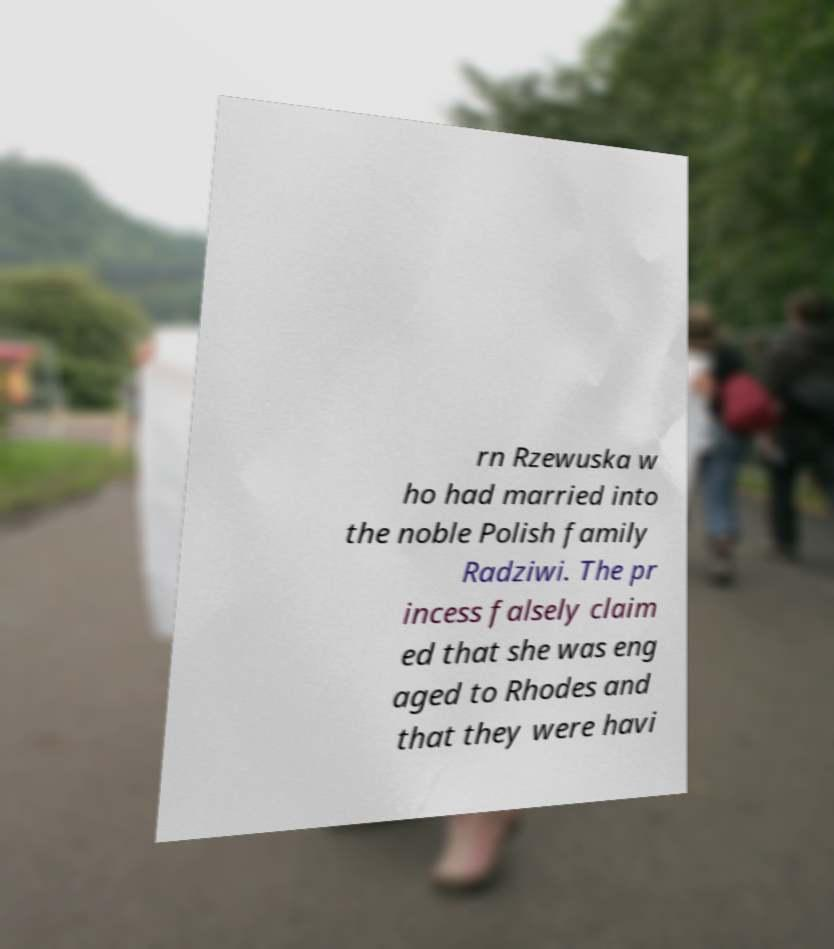Can you read and provide the text displayed in the image?This photo seems to have some interesting text. Can you extract and type it out for me? rn Rzewuska w ho had married into the noble Polish family Radziwi. The pr incess falsely claim ed that she was eng aged to Rhodes and that they were havi 